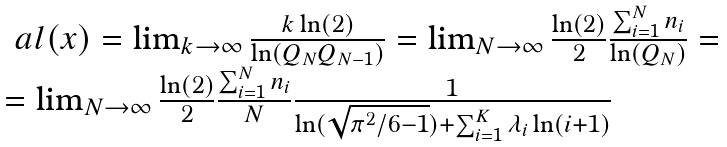Convert formula to latex. <formula><loc_0><loc_0><loc_500><loc_500>\begin{array} { l c l } \ a l ( x ) = \lim _ { k \to \infty } \frac { k \ln ( 2 ) } { \ln ( Q _ { N } Q _ { N - 1 } ) } = \lim _ { N \to \infty } \frac { \ln ( 2 ) } { 2 } \frac { \sum ^ { N } _ { i = 1 } n _ { i } } { \ln ( Q _ { N } ) } = \\ = \lim _ { N \to \infty } \frac { \ln ( 2 ) } { 2 } \frac { \sum ^ { N } _ { i = 1 } n _ { i } } { N } \frac { 1 } { \ln ( \sqrt { \pi ^ { 2 } / 6 - 1 } ) + \sum ^ { K } _ { i = 1 } \lambda _ { i } \ln ( i + 1 ) } \end{array}</formula> 